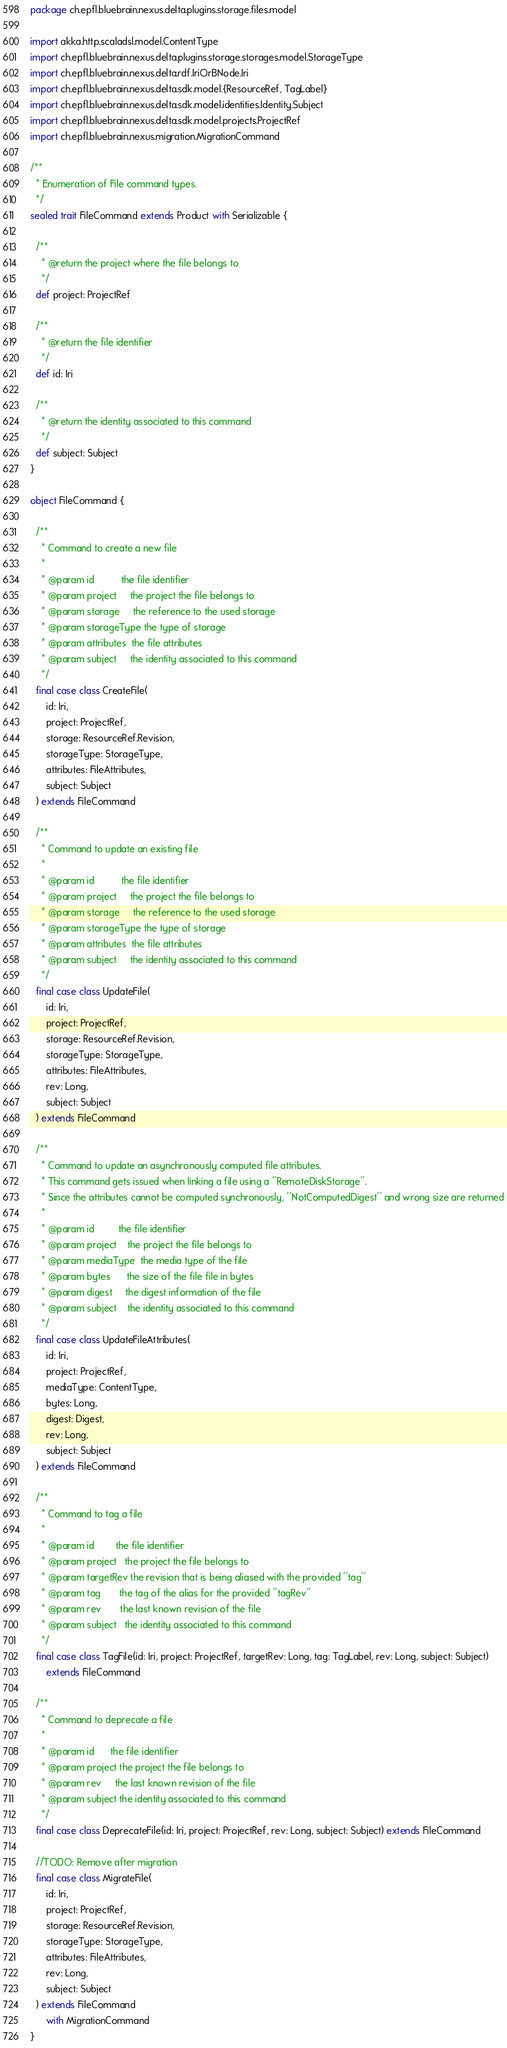<code> <loc_0><loc_0><loc_500><loc_500><_Scala_>package ch.epfl.bluebrain.nexus.delta.plugins.storage.files.model

import akka.http.scaladsl.model.ContentType
import ch.epfl.bluebrain.nexus.delta.plugins.storage.storages.model.StorageType
import ch.epfl.bluebrain.nexus.delta.rdf.IriOrBNode.Iri
import ch.epfl.bluebrain.nexus.delta.sdk.model.{ResourceRef, TagLabel}
import ch.epfl.bluebrain.nexus.delta.sdk.model.identities.Identity.Subject
import ch.epfl.bluebrain.nexus.delta.sdk.model.projects.ProjectRef
import ch.epfl.bluebrain.nexus.migration.MigrationCommand

/**
  * Enumeration of File command types.
  */
sealed trait FileCommand extends Product with Serializable {

  /**
    * @return the project where the file belongs to
    */
  def project: ProjectRef

  /**
    * @return the file identifier
    */
  def id: Iri

  /**
    * @return the identity associated to this command
    */
  def subject: Subject
}

object FileCommand {

  /**
    * Command to create a new file
    *
    * @param id          the file identifier
    * @param project     the project the file belongs to
    * @param storage     the reference to the used storage
    * @param storageType the type of storage
    * @param attributes  the file attributes
    * @param subject     the identity associated to this command
    */
  final case class CreateFile(
      id: Iri,
      project: ProjectRef,
      storage: ResourceRef.Revision,
      storageType: StorageType,
      attributes: FileAttributes,
      subject: Subject
  ) extends FileCommand

  /**
    * Command to update an existing file
    *
    * @param id          the file identifier
    * @param project     the project the file belongs to
    * @param storage     the reference to the used storage
    * @param storageType the type of storage
    * @param attributes  the file attributes
    * @param subject     the identity associated to this command
    */
  final case class UpdateFile(
      id: Iri,
      project: ProjectRef,
      storage: ResourceRef.Revision,
      storageType: StorageType,
      attributes: FileAttributes,
      rev: Long,
      subject: Subject
  ) extends FileCommand

  /**
    * Command to update an asynchronously computed file attributes.
    * This command gets issued when linking a file using a ''RemoteDiskStorage''.
    * Since the attributes cannot be computed synchronously, ''NotComputedDigest'' and wrong size are returned
    *
    * @param id         the file identifier
    * @param project    the project the file belongs to
    * @param mediaType  the media type of the file
    * @param bytes      the size of the file file in bytes
    * @param digest     the digest information of the file
    * @param subject    the identity associated to this command
    */
  final case class UpdateFileAttributes(
      id: Iri,
      project: ProjectRef,
      mediaType: ContentType,
      bytes: Long,
      digest: Digest,
      rev: Long,
      subject: Subject
  ) extends FileCommand

  /**
    * Command to tag a file
    *
    * @param id        the file identifier
    * @param project   the project the file belongs to
    * @param targetRev the revision that is being aliased with the provided ''tag''
    * @param tag       the tag of the alias for the provided ''tagRev''
    * @param rev       the last known revision of the file
    * @param subject   the identity associated to this command
    */
  final case class TagFile(id: Iri, project: ProjectRef, targetRev: Long, tag: TagLabel, rev: Long, subject: Subject)
      extends FileCommand

  /**
    * Command to deprecate a file
    *
    * @param id      the file identifier
    * @param project the project the file belongs to
    * @param rev     the last known revision of the file
    * @param subject the identity associated to this command
    */
  final case class DeprecateFile(id: Iri, project: ProjectRef, rev: Long, subject: Subject) extends FileCommand

  //TODO: Remove after migration
  final case class MigrateFile(
      id: Iri,
      project: ProjectRef,
      storage: ResourceRef.Revision,
      storageType: StorageType,
      attributes: FileAttributes,
      rev: Long,
      subject: Subject
  ) extends FileCommand
      with MigrationCommand
}
</code> 